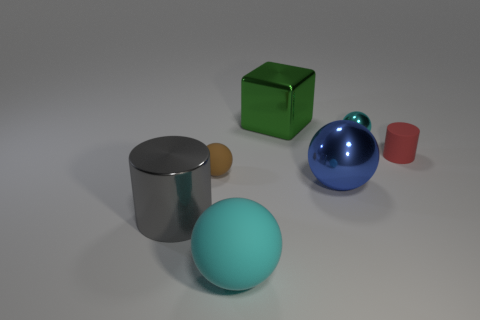Are there any other things of the same color as the small matte cylinder?
Provide a succinct answer. No. What number of things are either tiny rubber objects that are to the left of the cyan metallic sphere or cyan balls?
Your response must be concise. 3. Are the big blue sphere and the small cylinder made of the same material?
Your answer should be very brief. No. What size is the brown rubber object that is the same shape as the cyan metal thing?
Offer a very short reply. Small. There is a rubber object behind the brown object; does it have the same shape as the metal thing left of the large green cube?
Ensure brevity in your answer.  Yes. Do the gray metallic thing and the cyan thing that is behind the tiny red matte cylinder have the same size?
Keep it short and to the point. No. What number of other things are made of the same material as the tiny cyan thing?
Keep it short and to the point. 3. Are there any other things that are the same shape as the tiny cyan metallic thing?
Ensure brevity in your answer.  Yes. There is a cylinder on the left side of the tiny brown thing left of the metallic ball in front of the small shiny sphere; what is its color?
Your answer should be compact. Gray. There is a metallic object that is right of the small brown sphere and in front of the red cylinder; what shape is it?
Your response must be concise. Sphere. 